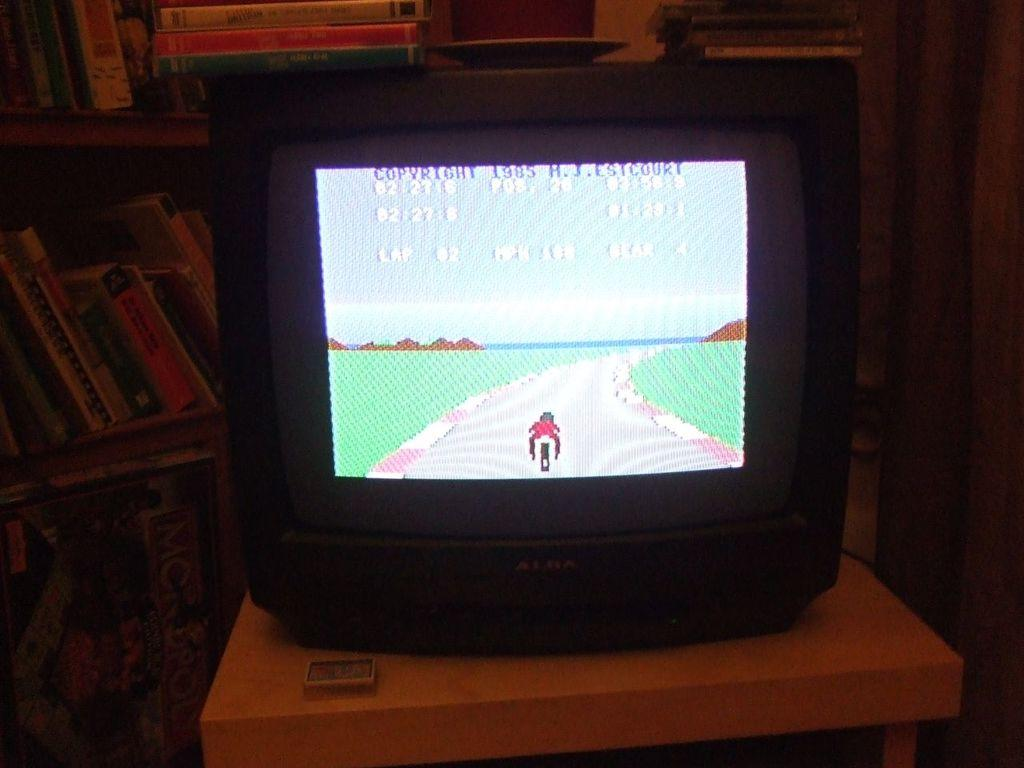<image>
Render a clear and concise summary of the photo. A game with a 1985 copyright is displayed on a television screen. 